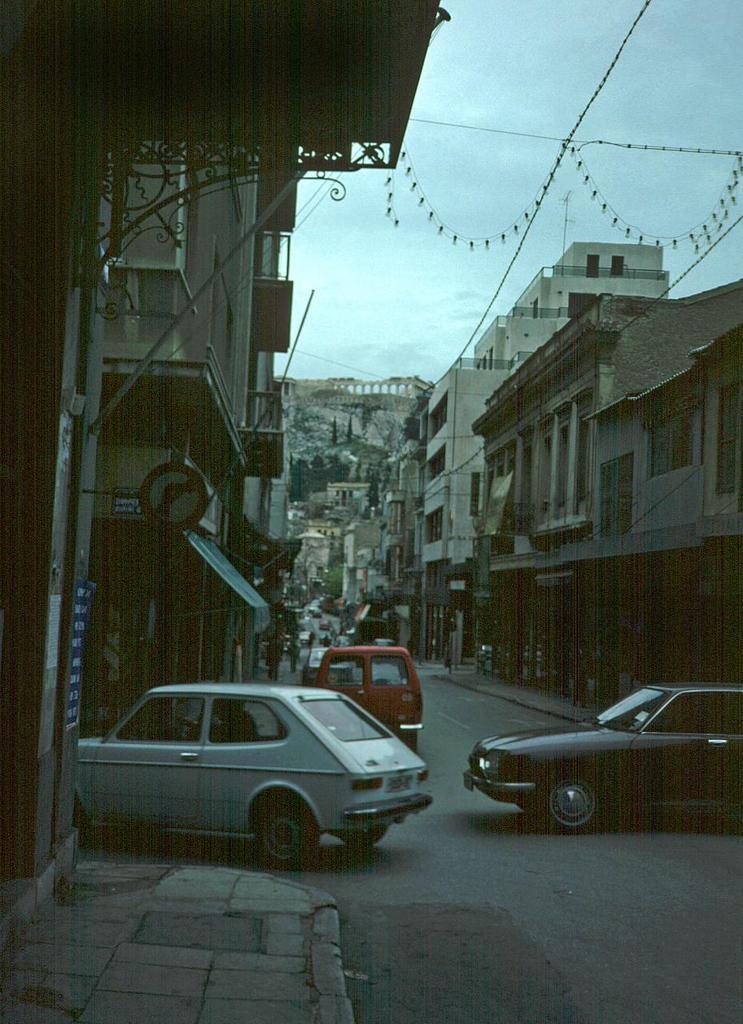Could you give a brief overview of what you see in this image? In this image, we can see so many buildings, sign board, rods, posters, walls, windows. At the bottom, there is a road and footpath. Few vehicles on the road. Background we can see few trees. Top of the image, there is a sky and wires. 